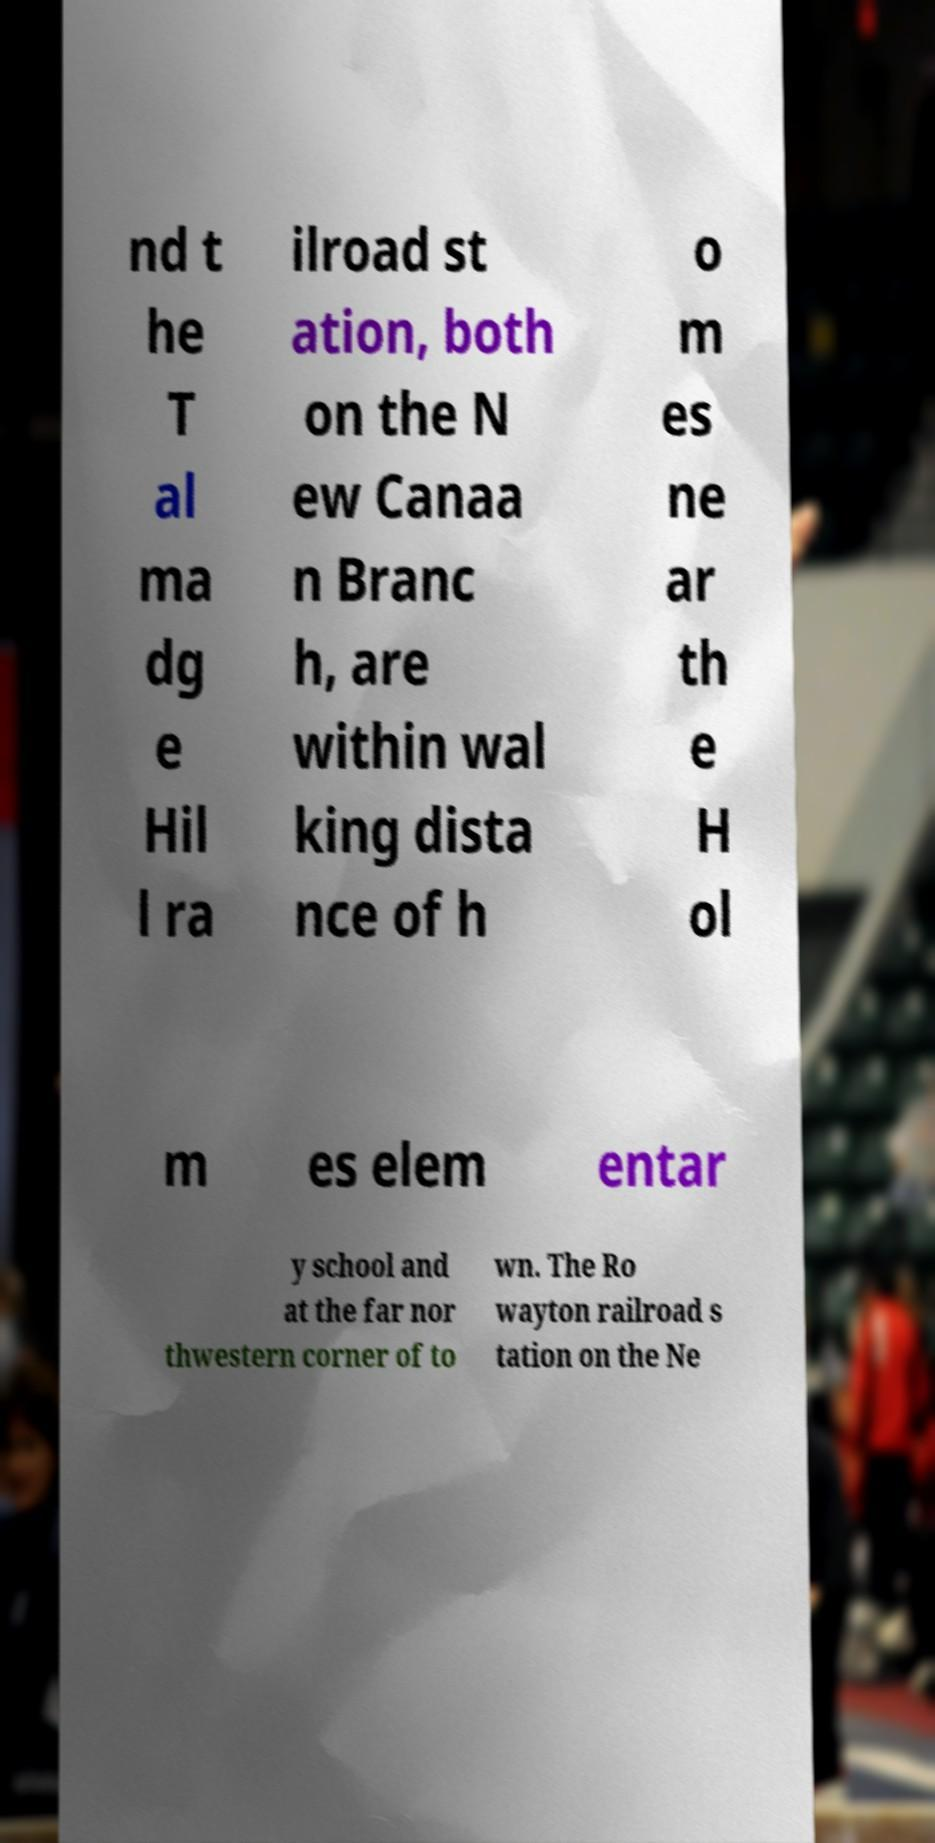Could you assist in decoding the text presented in this image and type it out clearly? nd t he T al ma dg e Hil l ra ilroad st ation, both on the N ew Canaa n Branc h, are within wal king dista nce of h o m es ne ar th e H ol m es elem entar y school and at the far nor thwestern corner of to wn. The Ro wayton railroad s tation on the Ne 